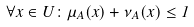<formula> <loc_0><loc_0><loc_500><loc_500>\forall x \in U \colon \mu _ { A } ( x ) + \nu _ { A } ( x ) \leq 1</formula> 